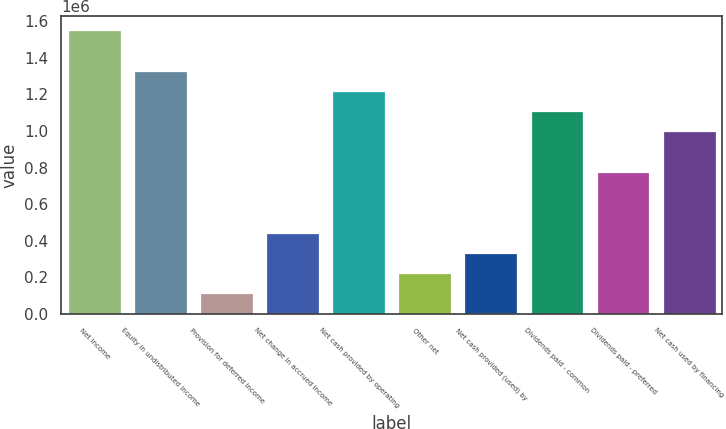<chart> <loc_0><loc_0><loc_500><loc_500><bar_chart><fcel>Net income<fcel>Equity in undistributed income<fcel>Provision for deferred income<fcel>Net change in accrued income<fcel>Net cash provided by operating<fcel>Other net<fcel>Net cash provided (used) by<fcel>Dividends paid - common<fcel>Dividends paid - preferred<fcel>Net cash used by financing<nl><fcel>1.55014e+06<fcel>1.32899e+06<fcel>112668<fcel>444392<fcel>1.21841e+06<fcel>223243<fcel>333818<fcel>1.10784e+06<fcel>776116<fcel>997264<nl></chart> 